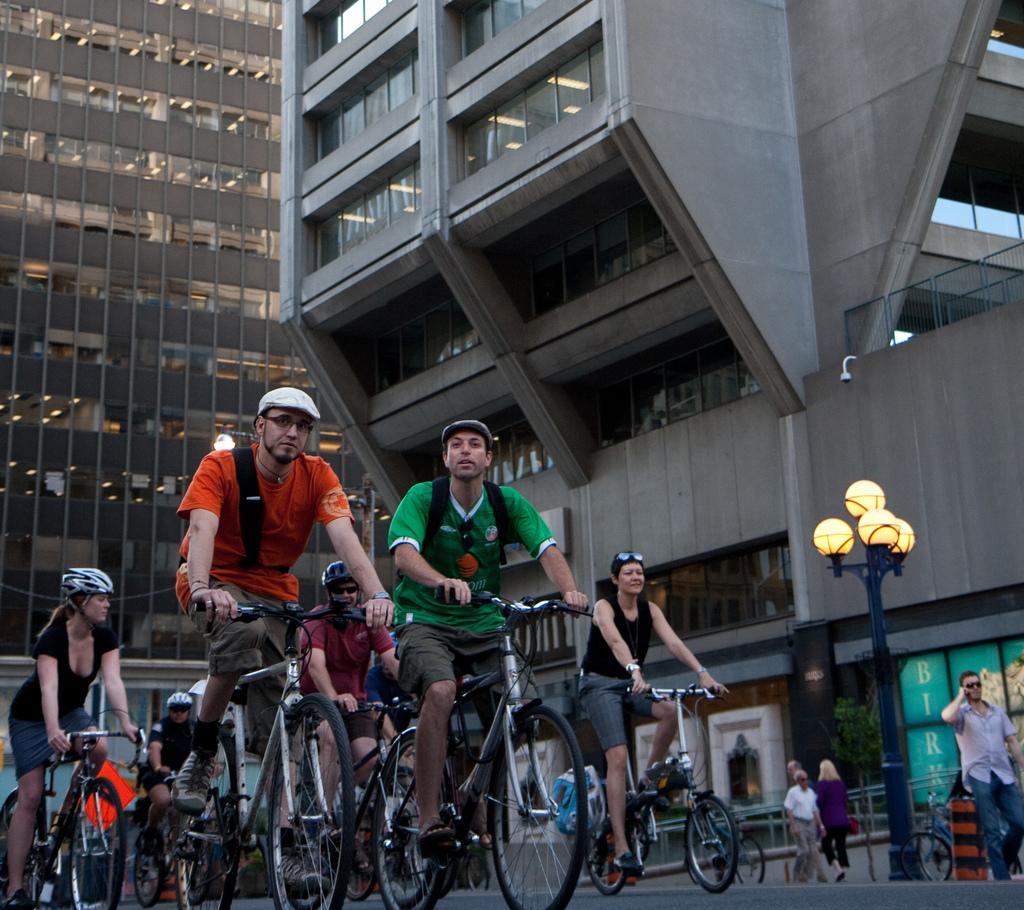Can you describe this image briefly? Most of the persons are riding a bicycle and wore helmet. These are buildings. This is a light pole. Far the persons are walking, as there is a leg movement. 